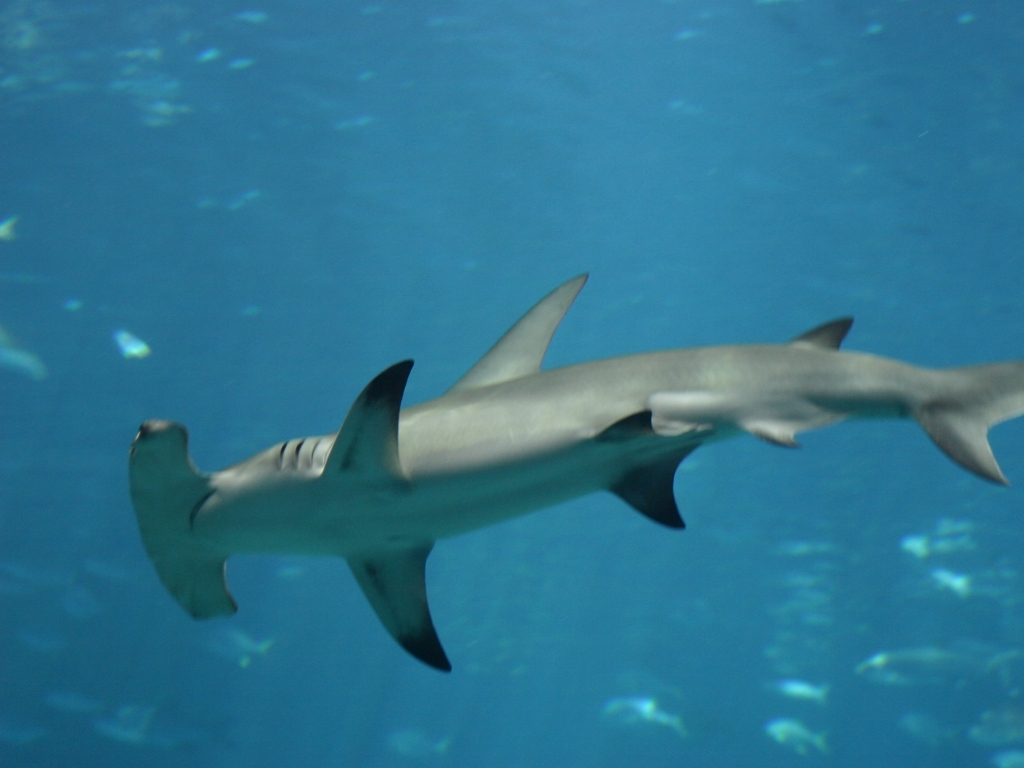Could you tell if this is a solitary shark or part of a larger group? While this image shows a single hammerhead shark, it's not uncommon for them to form schools during the day, sometimes numbering in the hundreds. These schools disband at night when the sharks go off to hunt. Without further context, it's hard to determine if this particular shark is solitary or part of a larger group out of frame. 